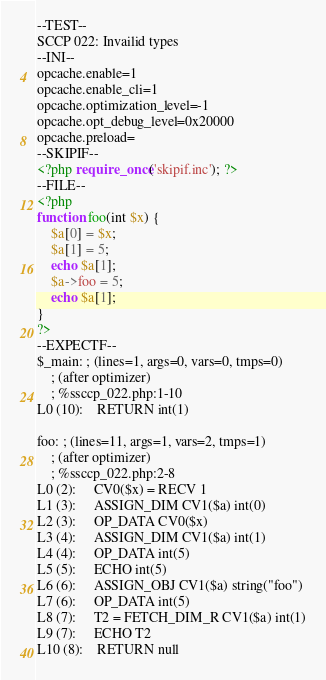Convert code to text. <code><loc_0><loc_0><loc_500><loc_500><_PHP_>--TEST--
SCCP 022: Invailid types
--INI--
opcache.enable=1
opcache.enable_cli=1
opcache.optimization_level=-1
opcache.opt_debug_level=0x20000
opcache.preload=
--SKIPIF--
<?php require_once('skipif.inc'); ?>
--FILE--
<?php
function foo(int $x) {
	$a[0] = $x;
	$a[1] = 5;
	echo $a[1];
	$a->foo = 5;
	echo $a[1];
}
?>
--EXPECTF--
$_main: ; (lines=1, args=0, vars=0, tmps=0)
    ; (after optimizer)
    ; %ssccp_022.php:1-10
L0 (10):    RETURN int(1)

foo: ; (lines=11, args=1, vars=2, tmps=1)
    ; (after optimizer)
    ; %ssccp_022.php:2-8
L0 (2):     CV0($x) = RECV 1
L1 (3):     ASSIGN_DIM CV1($a) int(0)
L2 (3):     OP_DATA CV0($x)
L3 (4):     ASSIGN_DIM CV1($a) int(1)
L4 (4):     OP_DATA int(5)
L5 (5):     ECHO int(5)
L6 (6):     ASSIGN_OBJ CV1($a) string("foo")
L7 (6):     OP_DATA int(5)
L8 (7):     T2 = FETCH_DIM_R CV1($a) int(1)
L9 (7):     ECHO T2
L10 (8):    RETURN null
</code> 